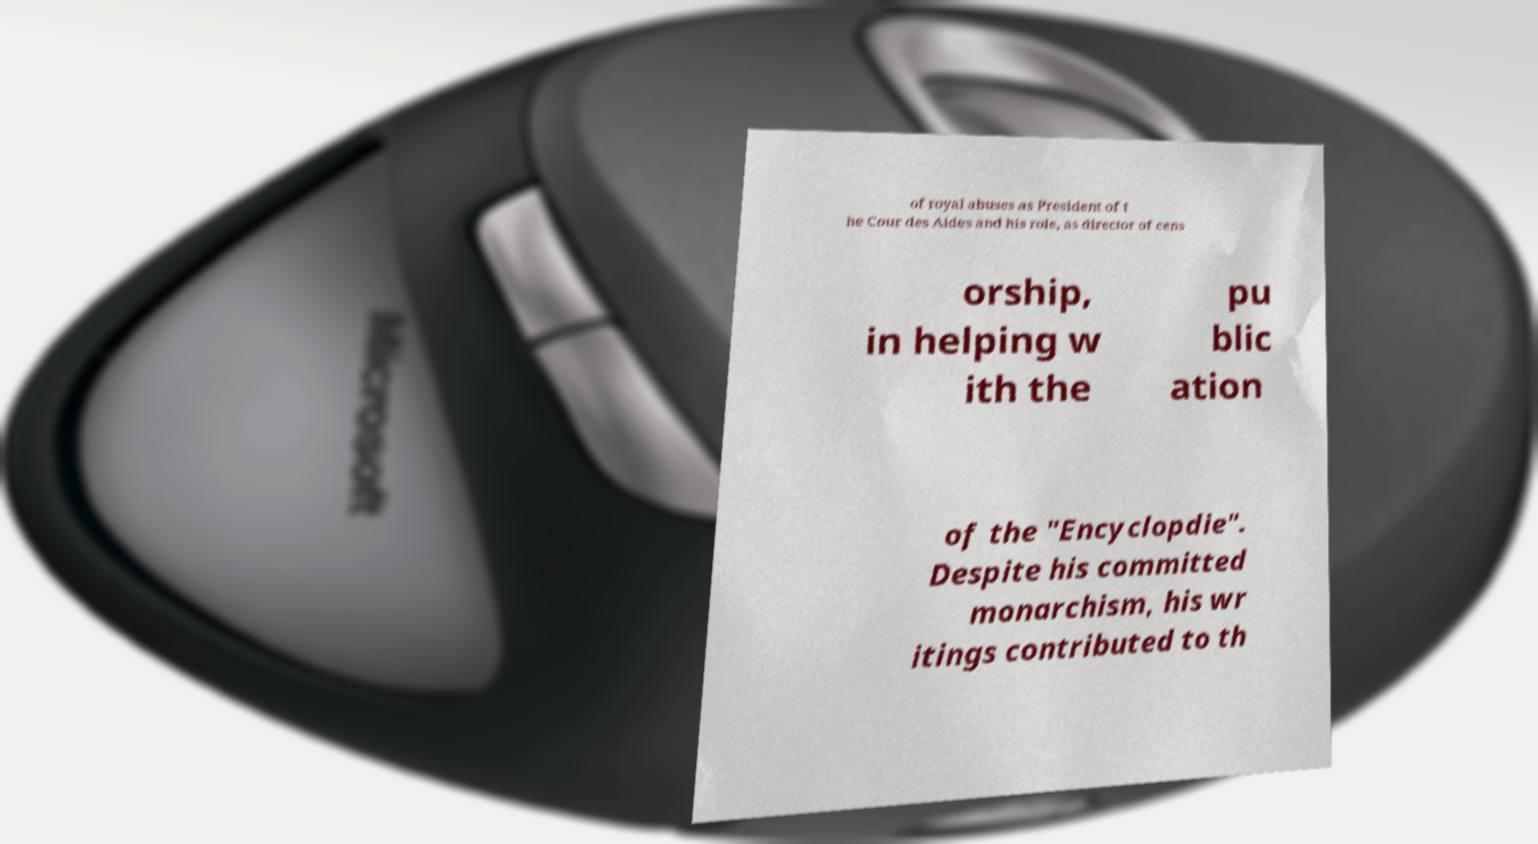Please identify and transcribe the text found in this image. of royal abuses as President of t he Cour des Aides and his role, as director of cens orship, in helping w ith the pu blic ation of the "Encyclopdie". Despite his committed monarchism, his wr itings contributed to th 